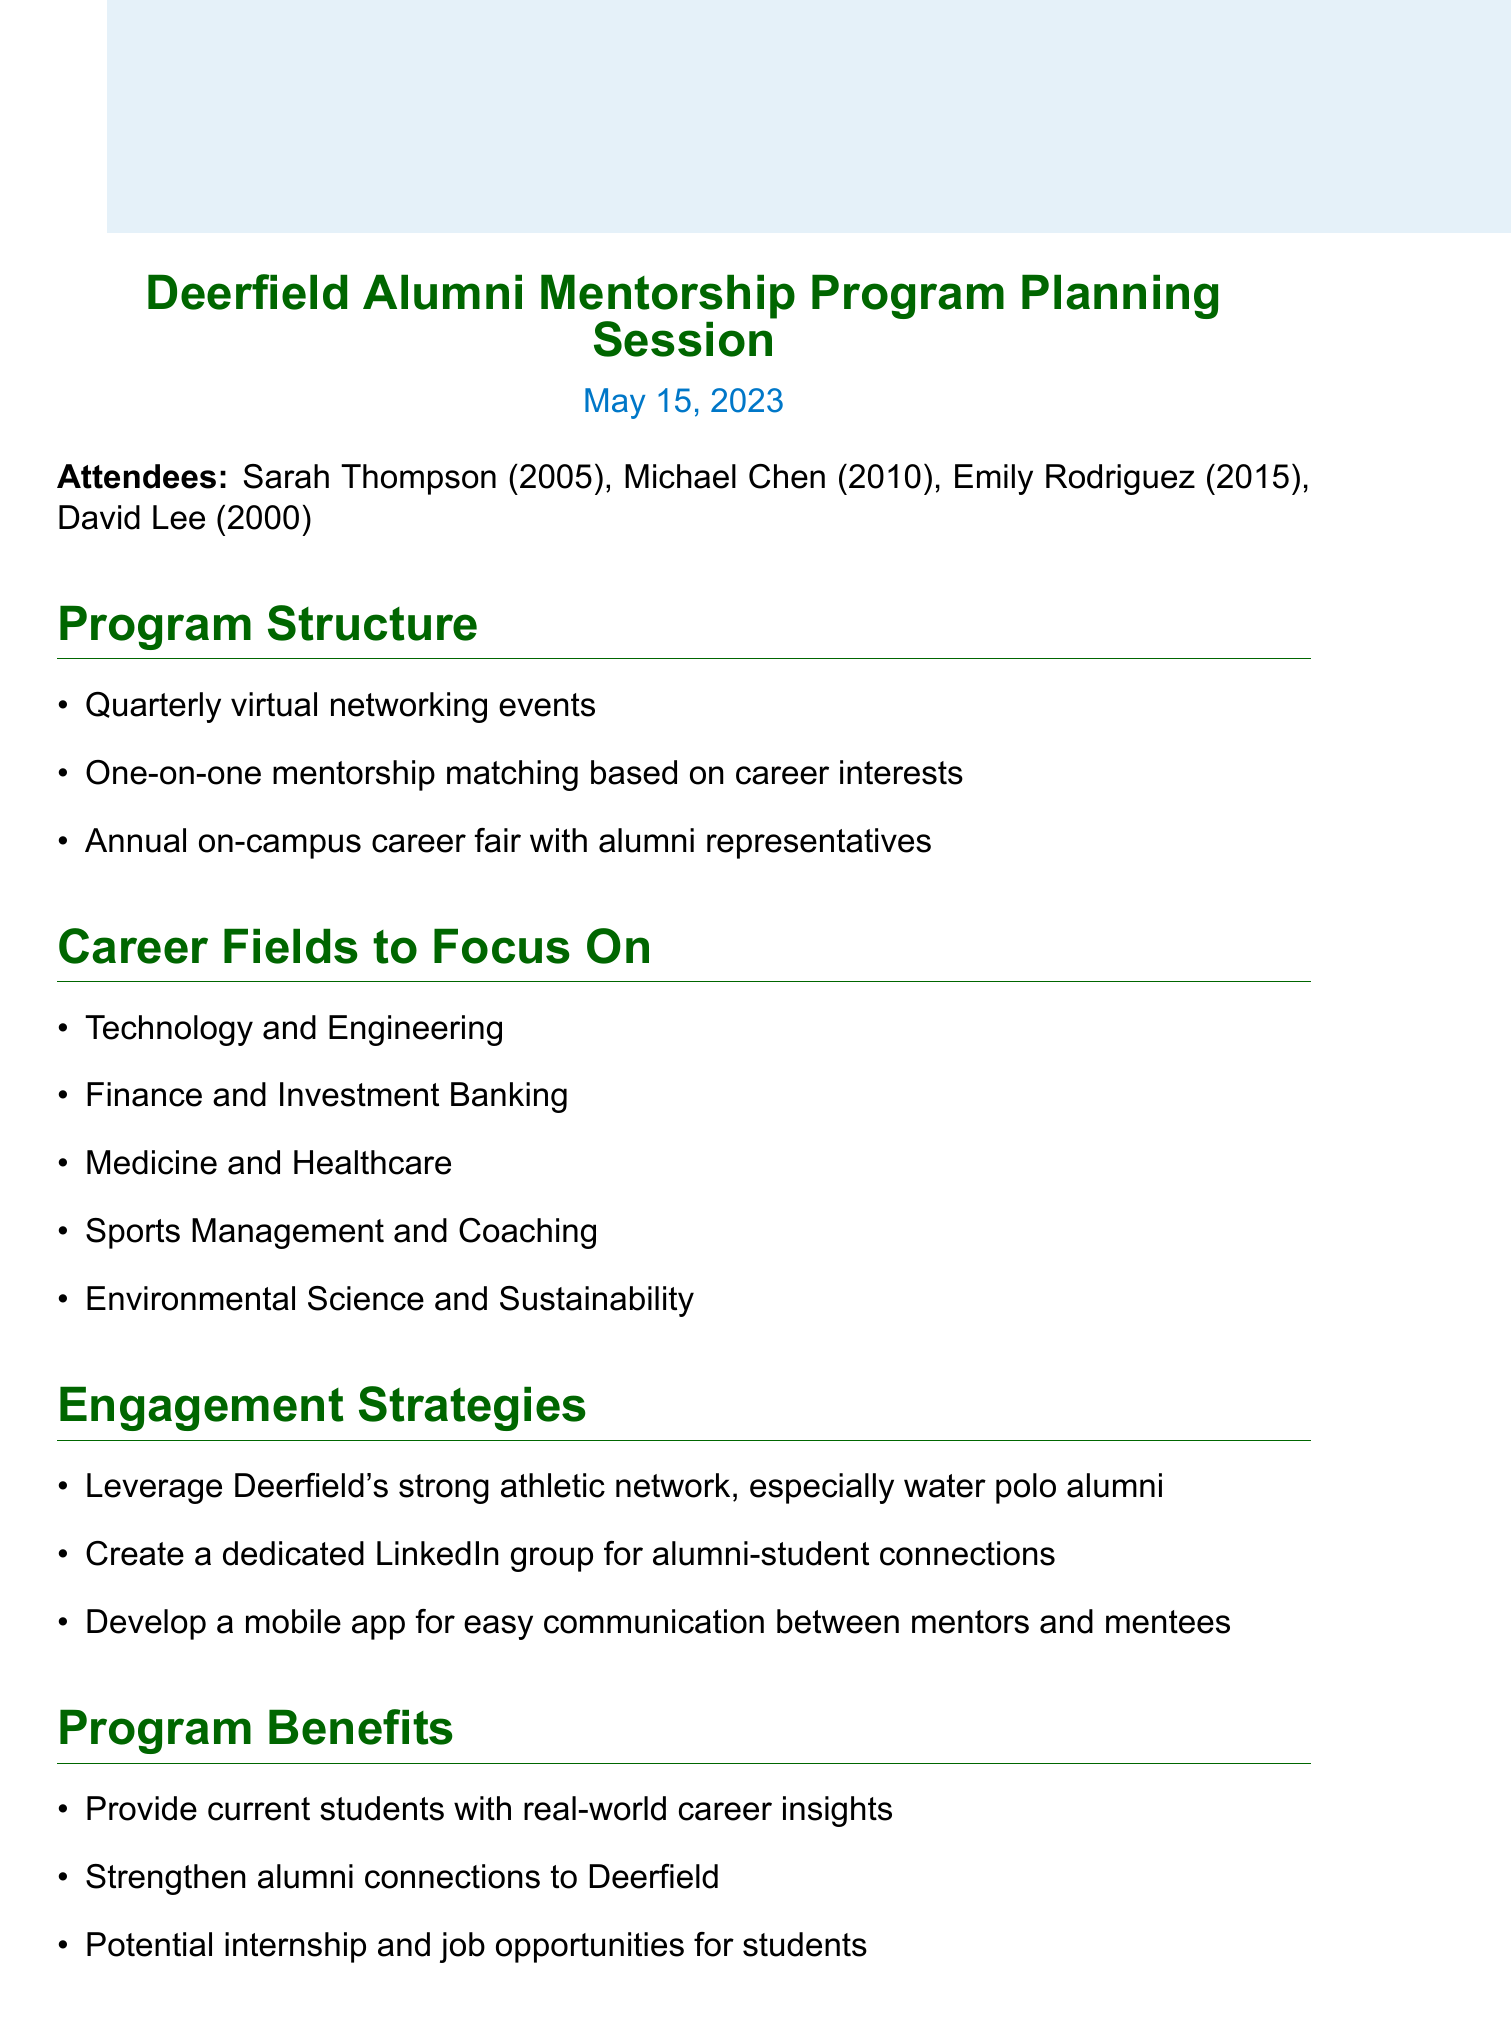What is the title of the meeting? The title of the meeting is specified at the beginning of the document.
Answer: Deerfield Alumni Mentorship Program Planning Session When did the meeting take place? The date of the meeting is clearly stated within the document.
Answer: May 15, 2023 Who is the Water Polo Team Captain from the Class of 2005? Sarah Thompson is identified as the Water Polo Team Captain in her attendee description.
Answer: Sarah Thompson What is one career field the program will focus on? The fields of focus are listed in the agenda and can be retrieved directly.
Answer: Technology and Engineering What is one engagement strategy mentioned in the document? The engagement strategies are enumerated, providing clear examples directly from the text.
Answer: Leverage Deerfield's strong athletic network How many action items are listed in the document? The total number of action items can be counted from the list provided.
Answer: 4 What is the proposed timeline for the pilot program? The timeline is clearly outlined in the document under the Implementation Timeline section.
Answer: Fall 2023 What is one benefit of the mentorship program? The benefits are listed, showing various positive impacts of the program.
Answer: Provide current students with real-world career insights Who is responsible for compiling potential corporate sponsors? The action item list specifies who is responsible for each task, including this one.
Answer: David 